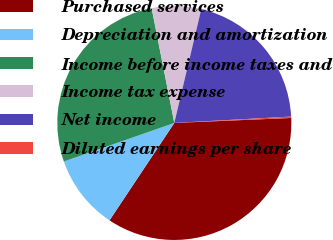<chart> <loc_0><loc_0><loc_500><loc_500><pie_chart><fcel>Purchased services<fcel>Depreciation and amortization<fcel>Income before income taxes and<fcel>Income tax expense<fcel>Net income<fcel>Diluted earnings per share<nl><fcel>35.02%<fcel>10.31%<fcel>27.24%<fcel>6.81%<fcel>20.43%<fcel>0.19%<nl></chart> 